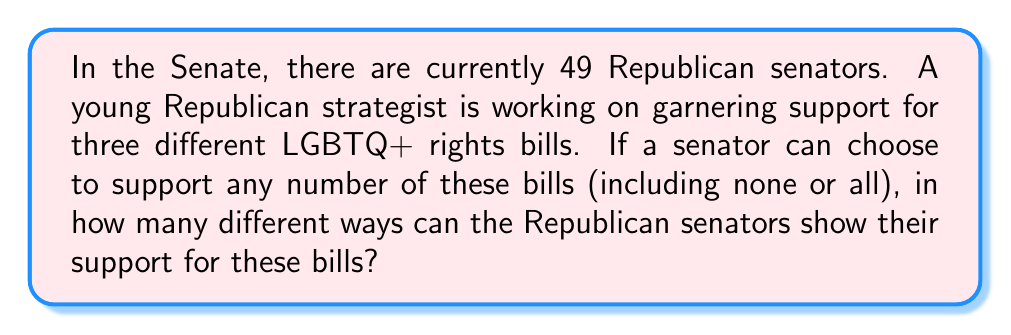Can you answer this question? Let's approach this step-by-step:

1) For each senator, there are two options for each bill: support or not support.

2) Since there are three bills, each senator has $2^3 = 8$ possible ways to show their support (or lack thereof):
   - Support no bills
   - Support only bill 1
   - Support only bill 2
   - Support only bill 3
   - Support bills 1 and 2
   - Support bills 1 and 3
   - Support bills 2 and 3
   - Support all three bills

3) This is a case of independent choices. Each senator's decision is independent of the others.

4) When we have independent choices, we multiply the number of options for each choice.

5) In this case, we have 49 senators, each with 8 options.

6) Therefore, the total number of ways the Republican senators can show their support is:

   $$8^{49}$$

This is because each of the 49 senators has 8 choices, and we multiply these together 49 times.

7) To calculate this:

   $$8^{49} = 2^{147} = 176,684,012,186,581,659,744,060,444,878,734,847,751,168$$
Answer: $8^{49} = 176,684,012,186,581,659,744,060,444,878,734,847,751,168$ ways 